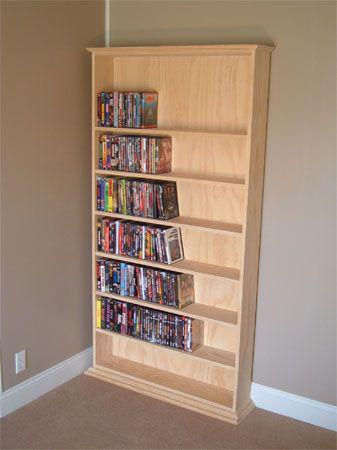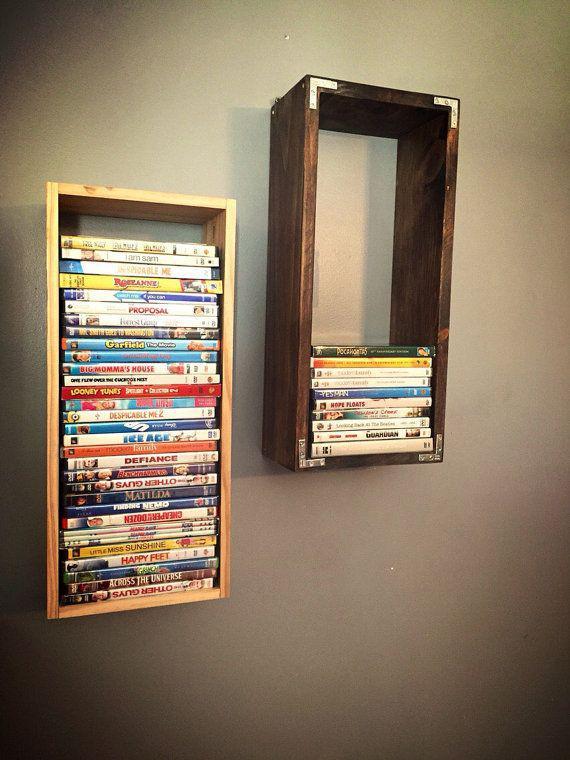The first image is the image on the left, the second image is the image on the right. For the images shown, is this caption "In one image, a wooden book shelf with six shelves is standing against a wall." true? Answer yes or no. Yes. 